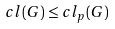<formula> <loc_0><loc_0><loc_500><loc_500>c l ( G ) \leq c l _ { p } ( G )</formula> 